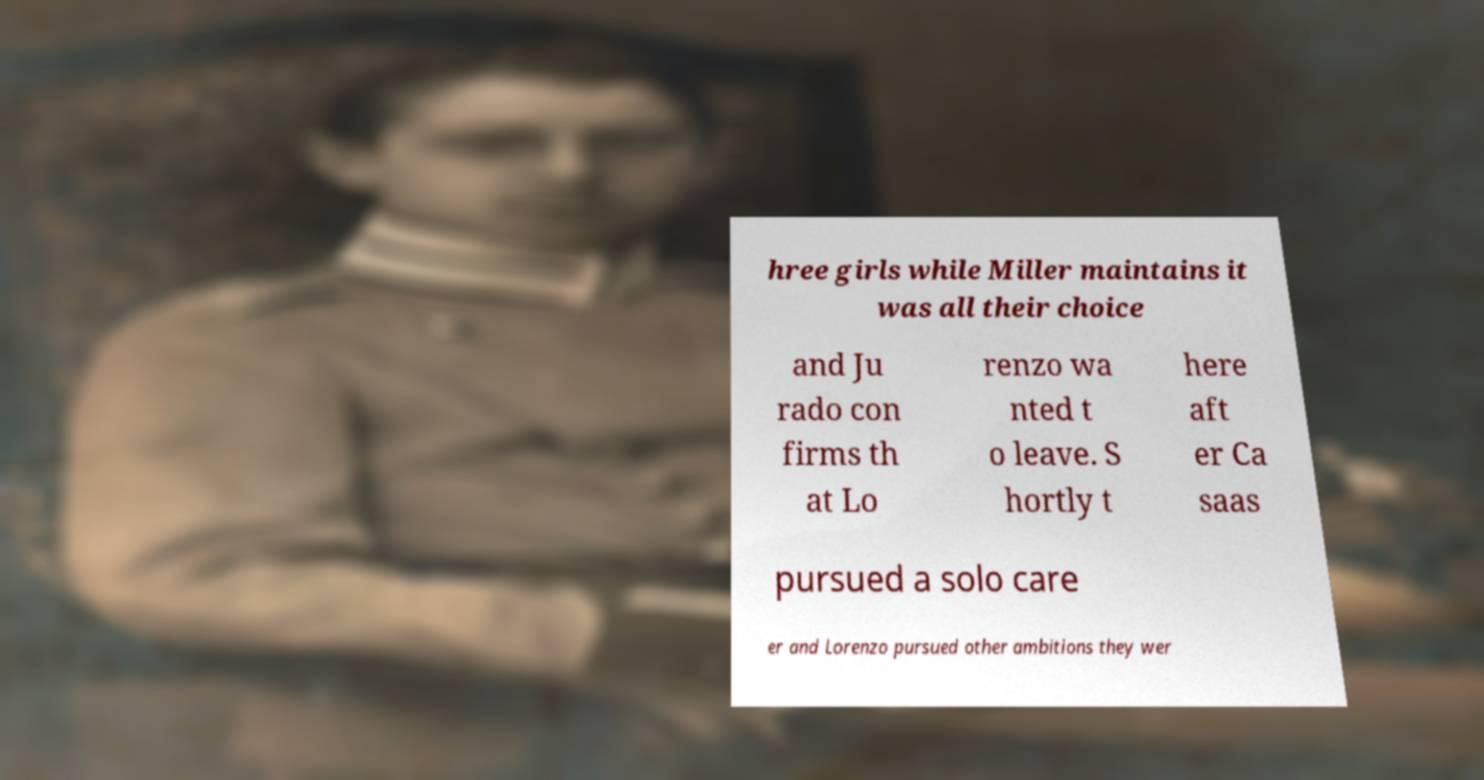Please identify and transcribe the text found in this image. hree girls while Miller maintains it was all their choice and Ju rado con firms th at Lo renzo wa nted t o leave. S hortly t here aft er Ca saas pursued a solo care er and Lorenzo pursued other ambitions they wer 